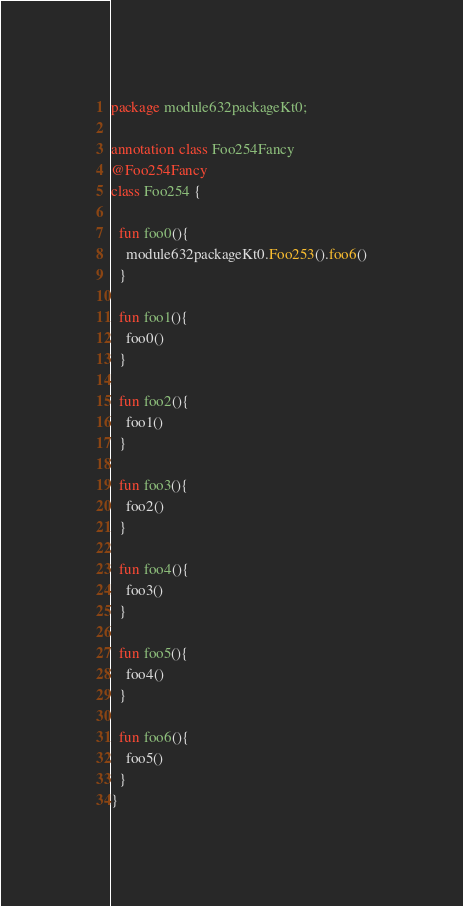<code> <loc_0><loc_0><loc_500><loc_500><_Kotlin_>package module632packageKt0;

annotation class Foo254Fancy
@Foo254Fancy
class Foo254 {

  fun foo0(){
    module632packageKt0.Foo253().foo6()
  }

  fun foo1(){
    foo0()
  }

  fun foo2(){
    foo1()
  }

  fun foo3(){
    foo2()
  }

  fun foo4(){
    foo3()
  }

  fun foo5(){
    foo4()
  }

  fun foo6(){
    foo5()
  }
}</code> 